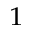<formula> <loc_0><loc_0><loc_500><loc_500>^ { 1 }</formula> 